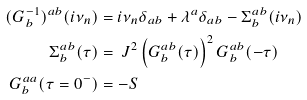<formula> <loc_0><loc_0><loc_500><loc_500>( G _ { b } ^ { - 1 } ) ^ { a b } ( i \nu _ { n } ) & = i \nu _ { n } \delta _ { a b } + \lambda ^ { a } \delta _ { a b } - \Sigma _ { b } ^ { a b } ( i \nu _ { n } ) \\ \Sigma ^ { a b } _ { b } ( \tau ) & = \ J ^ { 2 } \left ( G _ { b } ^ { a b } ( \tau ) \right ) ^ { 2 } G _ { b } ^ { a b } ( - \tau ) \\ G _ { b } ^ { a a } ( \tau = 0 ^ { - } ) & = - S</formula> 